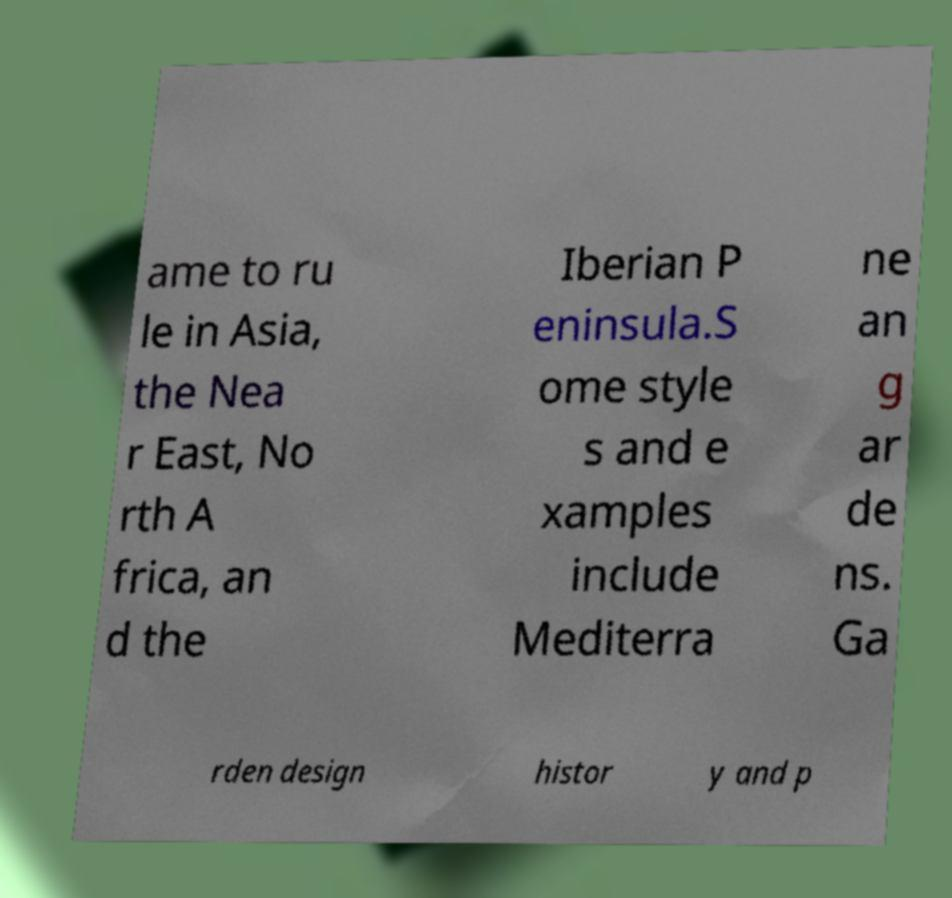I need the written content from this picture converted into text. Can you do that? ame to ru le in Asia, the Nea r East, No rth A frica, an d the Iberian P eninsula.S ome style s and e xamples include Mediterra ne an g ar de ns. Ga rden design histor y and p 